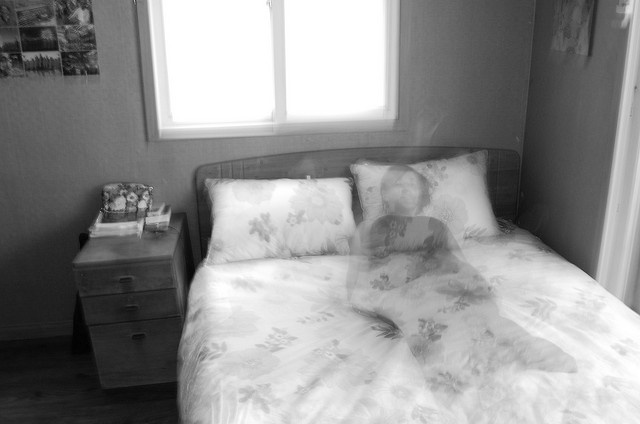Describe the objects in this image and their specific colors. I can see bed in black, lightgray, darkgray, and gray tones, people in darkgray, lightgray, gray, and black tones, and people in gray, black, and darkgray tones in this image. 